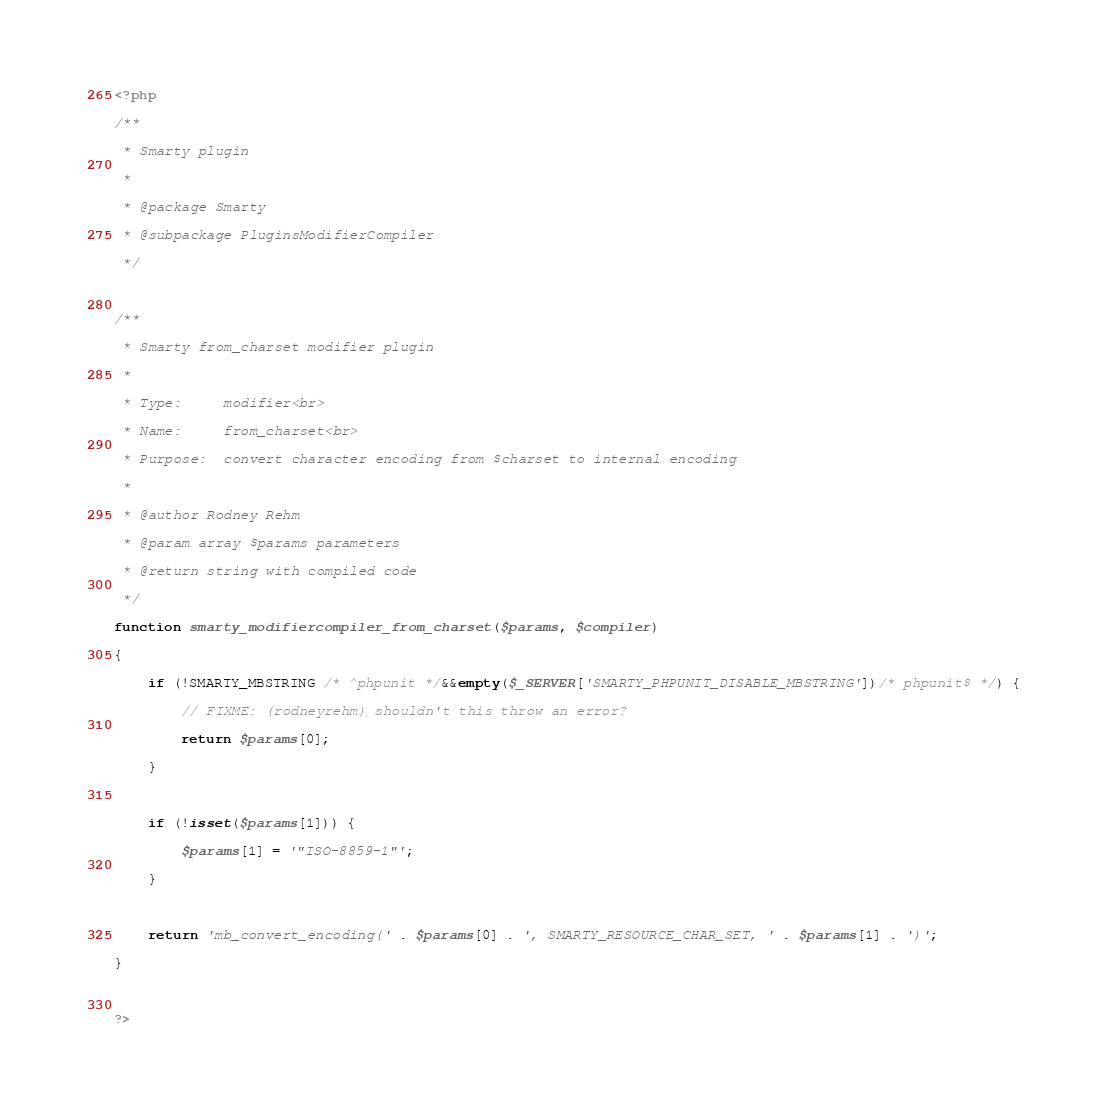Convert code to text. <code><loc_0><loc_0><loc_500><loc_500><_PHP_><?php
/**
 * Smarty plugin
 *
 * @package Smarty
 * @subpackage PluginsModifierCompiler
 */

/**
 * Smarty from_charset modifier plugin
 *
 * Type:     modifier<br>
 * Name:     from_charset<br>
 * Purpose:  convert character encoding from $charset to internal encoding
 *
 * @author Rodney Rehm
 * @param array $params parameters
 * @return string with compiled code
 */
function smarty_modifiercompiler_from_charset($params, $compiler)
{
    if (!SMARTY_MBSTRING /* ^phpunit */&&empty($_SERVER['SMARTY_PHPUNIT_DISABLE_MBSTRING'])/* phpunit$ */) {
        // FIXME: (rodneyrehm) shouldn't this throw an error?
        return $params[0];
    }

    if (!isset($params[1])) {
        $params[1] = '"ISO-8859-1"';
    }

    return 'mb_convert_encoding(' . $params[0] . ', SMARTY_RESOURCE_CHAR_SET, ' . $params[1] . ')';
}

?></code> 